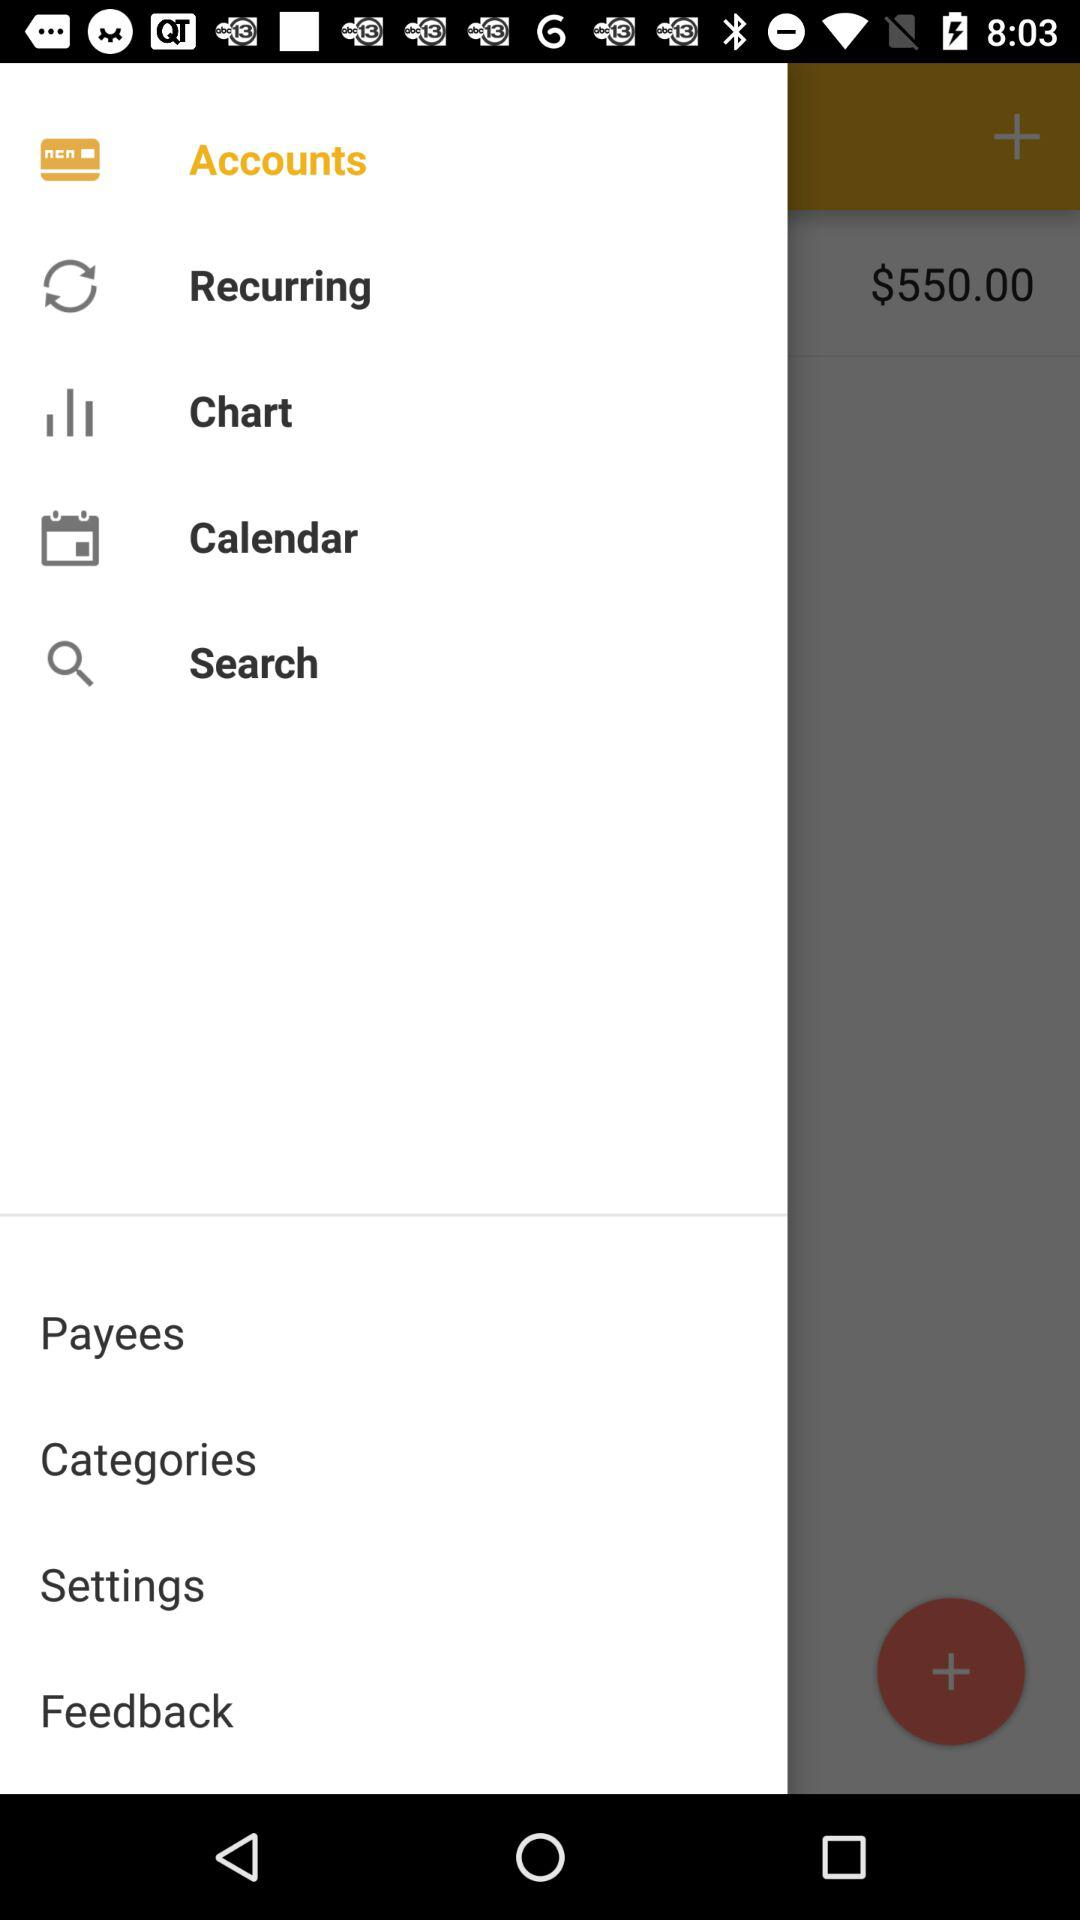Which item has been selected? The item that has been selected is "Accounts". 